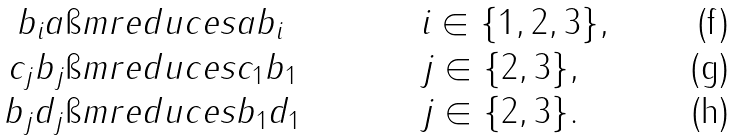<formula> <loc_0><loc_0><loc_500><loc_500>b _ { i } a & \i m r e d u c e s a b _ { i } & & i \in \{ 1 , 2 , 3 \} , \\ c _ { j } b _ { j } & \i m r e d u c e s c _ { 1 } b _ { 1 } & & j \in \{ 2 , 3 \} , \\ b _ { j } d _ { j } & \i m r e d u c e s b _ { 1 } d _ { 1 } & & j \in \{ 2 , 3 \} .</formula> 